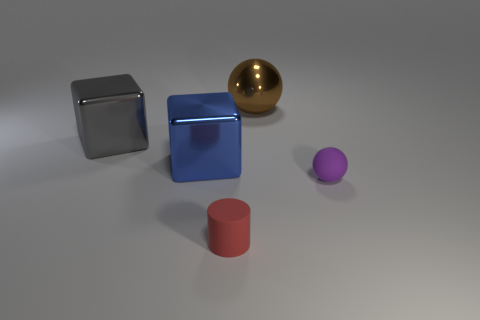Is the number of brown objects that are right of the brown metal thing greater than the number of tiny purple metal spheres?
Give a very brief answer. No. The tiny thing that is behind the small thing that is in front of the matte thing that is on the right side of the tiny red matte thing is made of what material?
Make the answer very short. Rubber. Is the small purple sphere made of the same material as the large gray block in front of the big brown metal object?
Your response must be concise. No. There is a large brown thing that is the same shape as the purple object; what is its material?
Give a very brief answer. Metal. Is there anything else that has the same material as the blue cube?
Offer a terse response. Yes. Are there more spheres that are in front of the red cylinder than small purple balls that are right of the tiny purple object?
Your answer should be very brief. No. The small red thing that is made of the same material as the purple thing is what shape?
Make the answer very short. Cylinder. What number of other things are the same shape as the large gray metal object?
Offer a very short reply. 1. What is the shape of the tiny rubber thing that is to the left of the tiny rubber sphere?
Your response must be concise. Cylinder. What is the color of the small matte sphere?
Your answer should be very brief. Purple. 